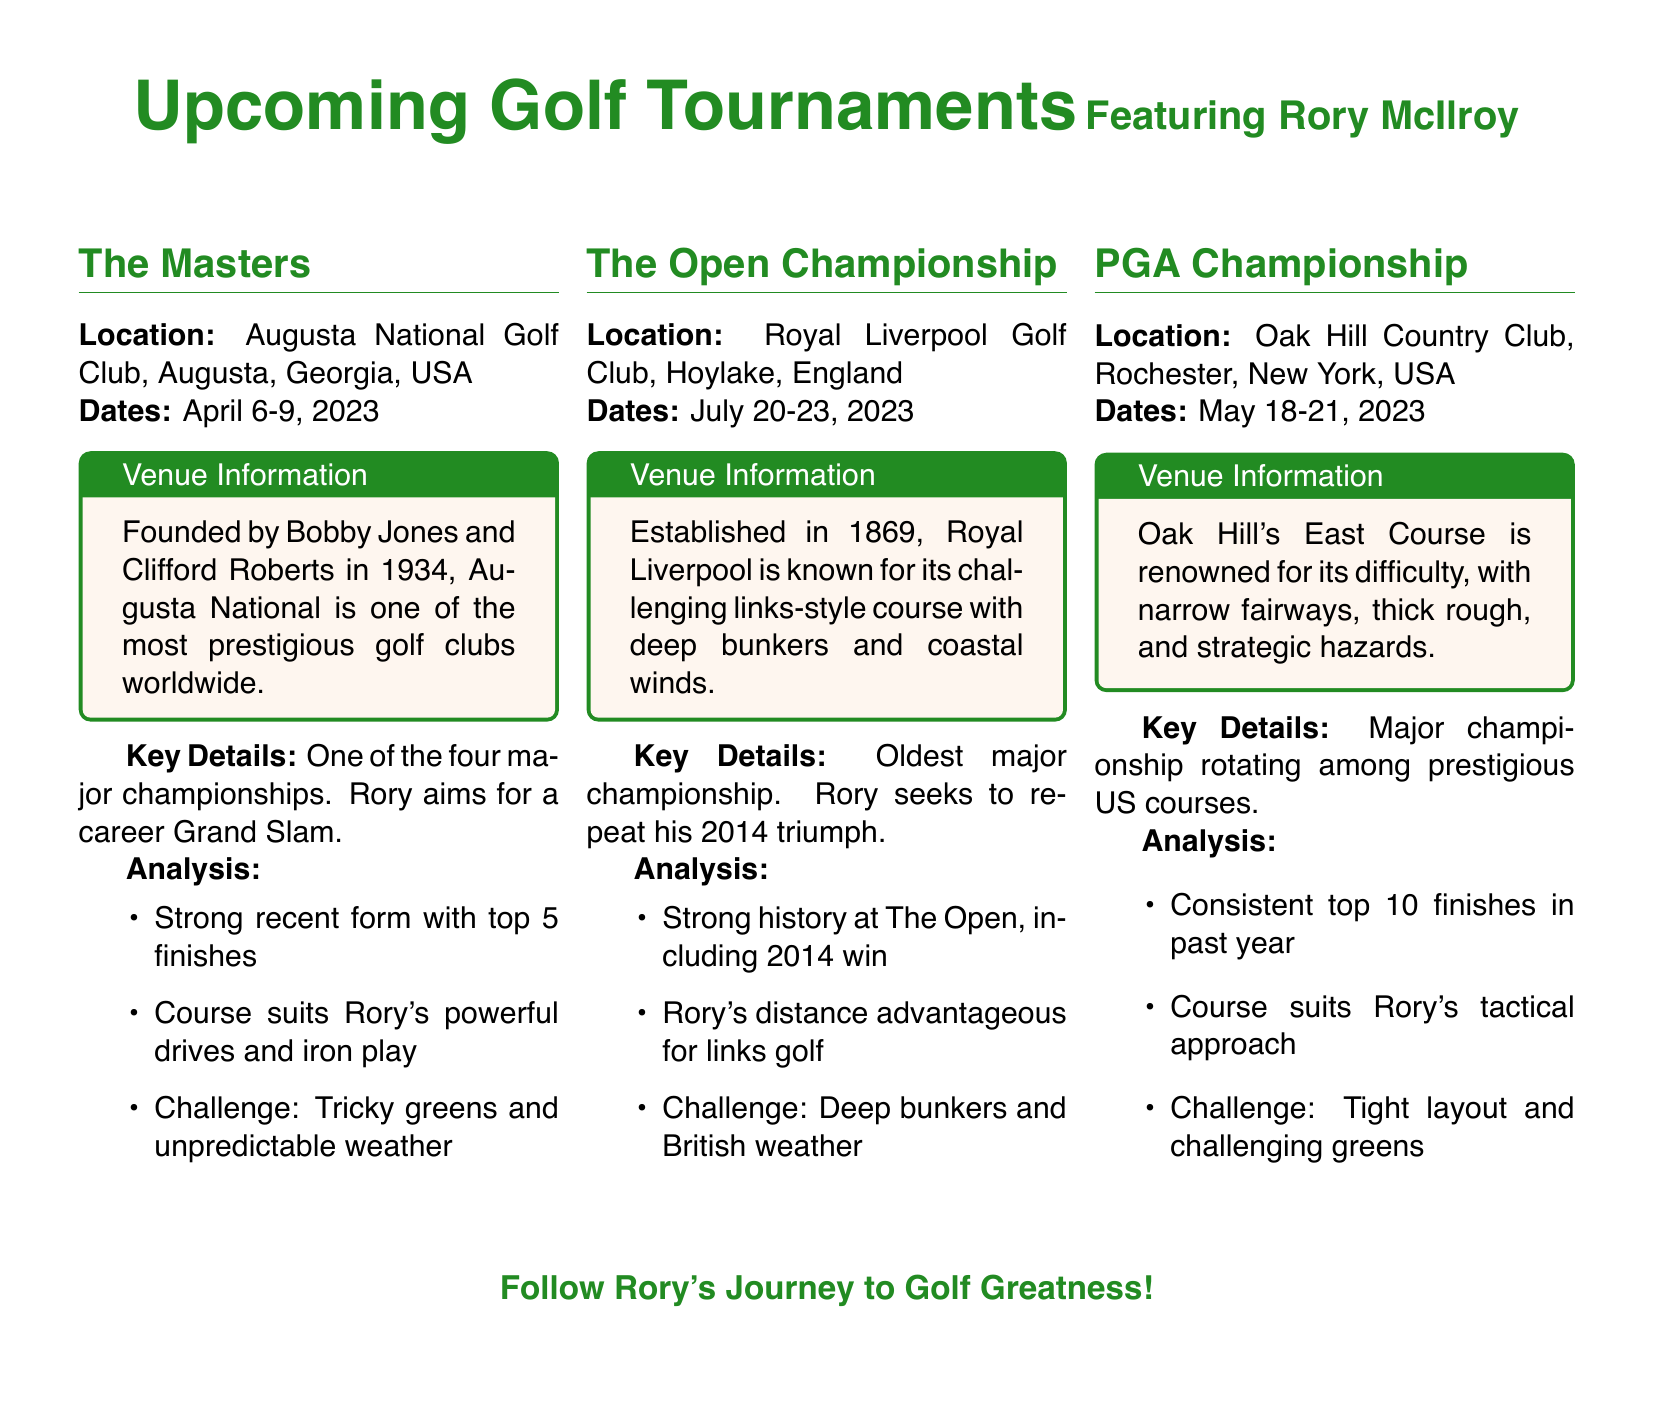What are the dates for The Masters? The dates for The Masters are mentioned directly in the document as April 6-9, 2023.
Answer: April 6-9, 2023 Where is the Open Championship held? The document specifies that the Open Championship is located at Royal Liverpool Golf Club, Hoylake, England.
Answer: Royal Liverpool Golf Club, Hoylake, England What is a key challenge at Augusta National? The document lists "Tricky greens and unpredictable weather" as challenges for players at Augusta National.
Answer: Tricky greens and unpredictable weather Which tournament does Rory McIlroy aim for a career Grand Slam? The document indicates that Rory aims for a career Grand Slam at The Masters.
Answer: The Masters What significant win is Rory seeking to replicate at The Open Championship? The document states that Rory seeks to repeat his 2014 triumph at The Open Championship.
Answer: 2014 triumph What is notable about Oak Hill Country Club? It is described in the document as renowned for its difficulty, which includes narrow fairways and thick rough.
Answer: Renowned for its difficulty What is Rory's recent finishing trend before the PGA Championship? The document mentions "Consistent top 10 finishes in past year" as Rory's recent performance trend.
Answer: Consistent top 10 finishes When is the PGA Championship scheduled? The document provides the dates for the PGA Championship as May 18-21, 2023.
Answer: May 18-21, 2023 What aspect of Rory's game gives him an advantage at The Open? The document states that Rory's distance is advantageous for links golf at The Open Championship.
Answer: Distance advantage for links golf 